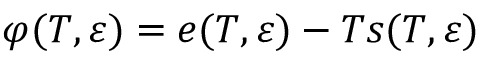<formula> <loc_0><loc_0><loc_500><loc_500>\varphi ( T , \boldsymbol \varepsilon ) = e ( T , \boldsymbol \varepsilon ) - T s ( T , \boldsymbol \varepsilon )</formula> 